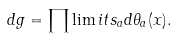<formula> <loc_0><loc_0><loc_500><loc_500>d g = \prod \lim i t s _ { a } d \theta _ { a } ( x ) .</formula> 